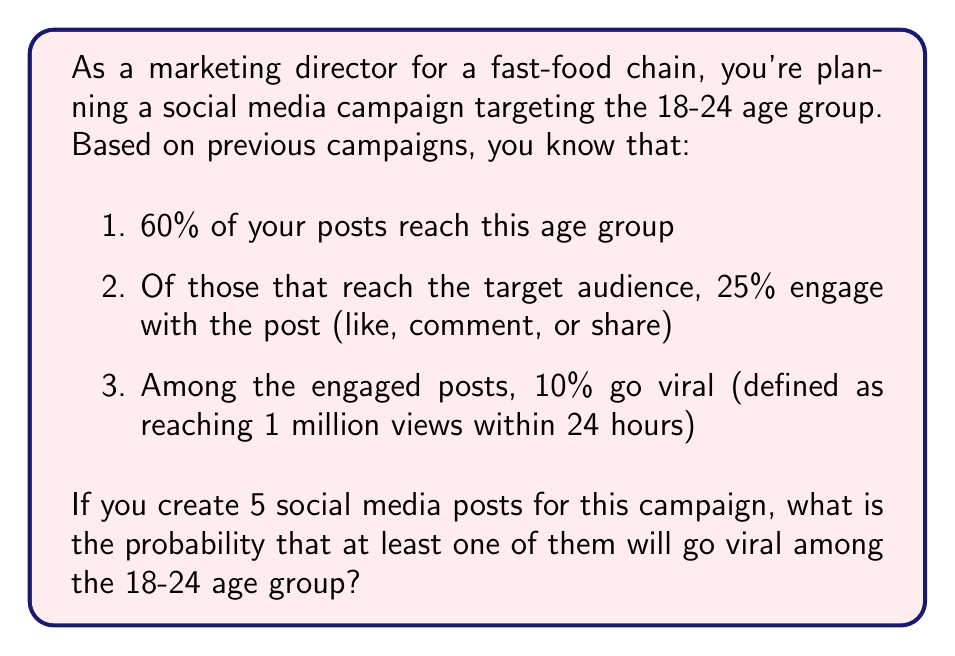Give your solution to this math problem. Let's approach this step-by-step:

1. First, let's calculate the probability of a single post going viral among the target audience:

   $P(\text{viral}) = 0.60 \times 0.25 \times 0.10 = 0.015 = 1.5\%$

2. Now, we need to find the probability of at least one post going viral out of 5 posts. It's easier to calculate the probability of no posts going viral and then subtract from 1:

   $P(\text{at least one viral}) = 1 - P(\text{no viral posts})$

3. The probability of no posts going viral is:

   $P(\text{no viral posts}) = (1 - 0.015)^5 = 0.985^5 \approx 0.9274$

4. Therefore, the probability of at least one post going viral is:

   $P(\text{at least one viral}) = 1 - 0.9274 = 0.0726$

5. Converting to a percentage:

   $0.0726 \times 100\% = 7.26\%$
Answer: The probability that at least one of the five social media posts will go viral among the 18-24 age group is approximately 7.26%. 